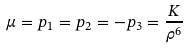Convert formula to latex. <formula><loc_0><loc_0><loc_500><loc_500>\mu = p _ { 1 } = p _ { 2 } = - p _ { 3 } = \frac { K } { \rho ^ { 6 } }</formula> 